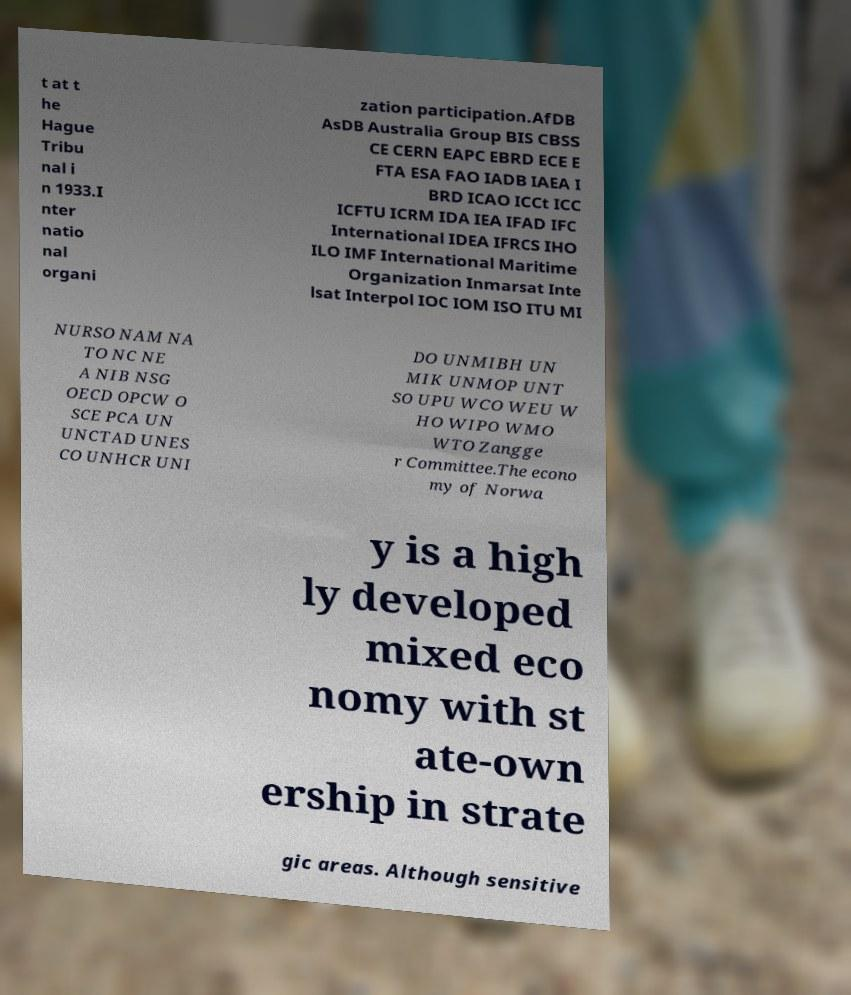What messages or text are displayed in this image? I need them in a readable, typed format. t at t he Hague Tribu nal i n 1933.I nter natio nal organi zation participation.AfDB AsDB Australia Group BIS CBSS CE CERN EAPC EBRD ECE E FTA ESA FAO IADB IAEA I BRD ICAO ICCt ICC ICFTU ICRM IDA IEA IFAD IFC International IDEA IFRCS IHO ILO IMF International Maritime Organization Inmarsat Inte lsat Interpol IOC IOM ISO ITU MI NURSO NAM NA TO NC NE A NIB NSG OECD OPCW O SCE PCA UN UNCTAD UNES CO UNHCR UNI DO UNMIBH UN MIK UNMOP UNT SO UPU WCO WEU W HO WIPO WMO WTO Zangge r Committee.The econo my of Norwa y is a high ly developed mixed eco nomy with st ate-own ership in strate gic areas. Although sensitive 